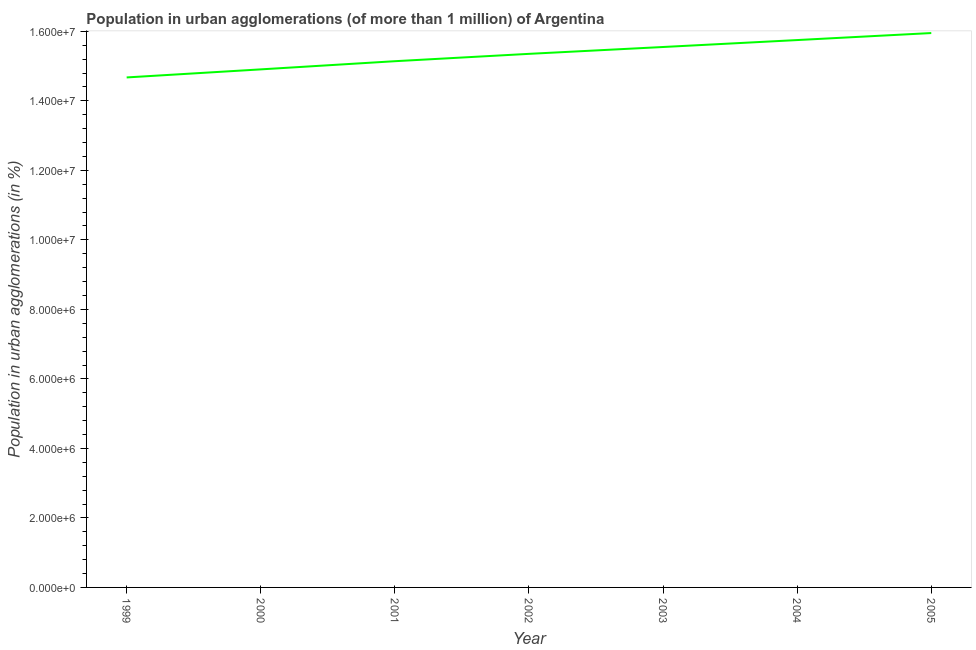What is the population in urban agglomerations in 1999?
Your response must be concise. 1.47e+07. Across all years, what is the maximum population in urban agglomerations?
Provide a short and direct response. 1.60e+07. Across all years, what is the minimum population in urban agglomerations?
Ensure brevity in your answer.  1.47e+07. In which year was the population in urban agglomerations minimum?
Provide a short and direct response. 1999. What is the sum of the population in urban agglomerations?
Your answer should be very brief. 1.07e+08. What is the difference between the population in urban agglomerations in 2000 and 2005?
Give a very brief answer. -1.05e+06. What is the average population in urban agglomerations per year?
Your answer should be very brief. 1.53e+07. What is the median population in urban agglomerations?
Provide a short and direct response. 1.54e+07. What is the ratio of the population in urban agglomerations in 2002 to that in 2003?
Provide a succinct answer. 0.99. Is the population in urban agglomerations in 2000 less than that in 2003?
Offer a terse response. Yes. What is the difference between the highest and the second highest population in urban agglomerations?
Your response must be concise. 2.02e+05. What is the difference between the highest and the lowest population in urban agglomerations?
Provide a short and direct response. 1.28e+06. In how many years, is the population in urban agglomerations greater than the average population in urban agglomerations taken over all years?
Make the answer very short. 4. Does the population in urban agglomerations monotonically increase over the years?
Offer a terse response. Yes. How many years are there in the graph?
Your response must be concise. 7. What is the difference between two consecutive major ticks on the Y-axis?
Make the answer very short. 2.00e+06. Are the values on the major ticks of Y-axis written in scientific E-notation?
Ensure brevity in your answer.  Yes. Does the graph contain grids?
Ensure brevity in your answer.  No. What is the title of the graph?
Ensure brevity in your answer.  Population in urban agglomerations (of more than 1 million) of Argentina. What is the label or title of the Y-axis?
Your response must be concise. Population in urban agglomerations (in %). What is the Population in urban agglomerations (in %) in 1999?
Your answer should be compact. 1.47e+07. What is the Population in urban agglomerations (in %) in 2000?
Offer a terse response. 1.49e+07. What is the Population in urban agglomerations (in %) in 2001?
Provide a short and direct response. 1.51e+07. What is the Population in urban agglomerations (in %) of 2002?
Keep it short and to the point. 1.54e+07. What is the Population in urban agglomerations (in %) of 2003?
Offer a terse response. 1.56e+07. What is the Population in urban agglomerations (in %) in 2004?
Your answer should be very brief. 1.58e+07. What is the Population in urban agglomerations (in %) in 2005?
Offer a very short reply. 1.60e+07. What is the difference between the Population in urban agglomerations (in %) in 1999 and 2000?
Give a very brief answer. -2.32e+05. What is the difference between the Population in urban agglomerations (in %) in 1999 and 2001?
Keep it short and to the point. -4.67e+05. What is the difference between the Population in urban agglomerations (in %) in 1999 and 2002?
Ensure brevity in your answer.  -6.79e+05. What is the difference between the Population in urban agglomerations (in %) in 1999 and 2003?
Your answer should be compact. -8.76e+05. What is the difference between the Population in urban agglomerations (in %) in 1999 and 2004?
Ensure brevity in your answer.  -1.08e+06. What is the difference between the Population in urban agglomerations (in %) in 1999 and 2005?
Ensure brevity in your answer.  -1.28e+06. What is the difference between the Population in urban agglomerations (in %) in 2000 and 2001?
Offer a very short reply. -2.35e+05. What is the difference between the Population in urban agglomerations (in %) in 2000 and 2002?
Your answer should be very brief. -4.47e+05. What is the difference between the Population in urban agglomerations (in %) in 2000 and 2003?
Provide a succinct answer. -6.44e+05. What is the difference between the Population in urban agglomerations (in %) in 2000 and 2004?
Give a very brief answer. -8.43e+05. What is the difference between the Population in urban agglomerations (in %) in 2000 and 2005?
Your answer should be very brief. -1.05e+06. What is the difference between the Population in urban agglomerations (in %) in 2001 and 2002?
Keep it short and to the point. -2.12e+05. What is the difference between the Population in urban agglomerations (in %) in 2001 and 2003?
Make the answer very short. -4.09e+05. What is the difference between the Population in urban agglomerations (in %) in 2001 and 2004?
Make the answer very short. -6.08e+05. What is the difference between the Population in urban agglomerations (in %) in 2001 and 2005?
Ensure brevity in your answer.  -8.10e+05. What is the difference between the Population in urban agglomerations (in %) in 2002 and 2003?
Make the answer very short. -1.97e+05. What is the difference between the Population in urban agglomerations (in %) in 2002 and 2004?
Your answer should be very brief. -3.97e+05. What is the difference between the Population in urban agglomerations (in %) in 2002 and 2005?
Provide a short and direct response. -5.99e+05. What is the difference between the Population in urban agglomerations (in %) in 2003 and 2004?
Ensure brevity in your answer.  -2.00e+05. What is the difference between the Population in urban agglomerations (in %) in 2003 and 2005?
Give a very brief answer. -4.02e+05. What is the difference between the Population in urban agglomerations (in %) in 2004 and 2005?
Keep it short and to the point. -2.02e+05. What is the ratio of the Population in urban agglomerations (in %) in 1999 to that in 2000?
Provide a succinct answer. 0.98. What is the ratio of the Population in urban agglomerations (in %) in 1999 to that in 2001?
Offer a terse response. 0.97. What is the ratio of the Population in urban agglomerations (in %) in 1999 to that in 2002?
Provide a short and direct response. 0.96. What is the ratio of the Population in urban agglomerations (in %) in 1999 to that in 2003?
Give a very brief answer. 0.94. What is the ratio of the Population in urban agglomerations (in %) in 1999 to that in 2004?
Keep it short and to the point. 0.93. What is the ratio of the Population in urban agglomerations (in %) in 2000 to that in 2001?
Make the answer very short. 0.98. What is the ratio of the Population in urban agglomerations (in %) in 2000 to that in 2004?
Your answer should be very brief. 0.95. What is the ratio of the Population in urban agglomerations (in %) in 2000 to that in 2005?
Offer a very short reply. 0.93. What is the ratio of the Population in urban agglomerations (in %) in 2001 to that in 2003?
Keep it short and to the point. 0.97. What is the ratio of the Population in urban agglomerations (in %) in 2001 to that in 2004?
Ensure brevity in your answer.  0.96. What is the ratio of the Population in urban agglomerations (in %) in 2001 to that in 2005?
Ensure brevity in your answer.  0.95. 